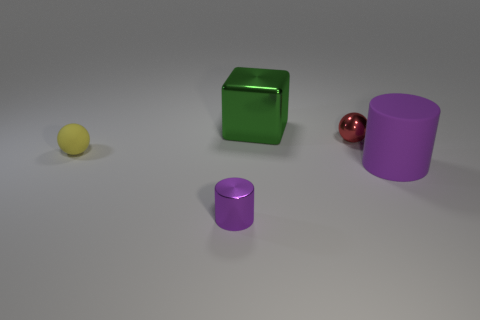There is a ball that is on the left side of the metal object that is to the left of the large green shiny cube; what is its color?
Offer a terse response. Yellow. There is a red sphere that is made of the same material as the block; what size is it?
Give a very brief answer. Small. What number of other large matte things have the same shape as the green thing?
Provide a succinct answer. 0. What number of things are either small metallic objects on the left side of the small red metallic thing or rubber things that are behind the purple matte thing?
Provide a succinct answer. 2. How many metal things are on the right side of the metal thing in front of the tiny yellow ball?
Give a very brief answer. 2. There is a matte object that is behind the large matte thing; is it the same shape as the tiny thing that is on the right side of the green shiny object?
Your answer should be compact. Yes. What is the shape of the large matte object that is the same color as the tiny metal cylinder?
Provide a succinct answer. Cylinder. Is there a tiny yellow ball made of the same material as the large cylinder?
Your answer should be very brief. Yes. How many rubber things are brown objects or blocks?
Offer a terse response. 0. What shape is the tiny metal thing behind the purple cylinder that is to the right of the small red shiny thing?
Make the answer very short. Sphere. 